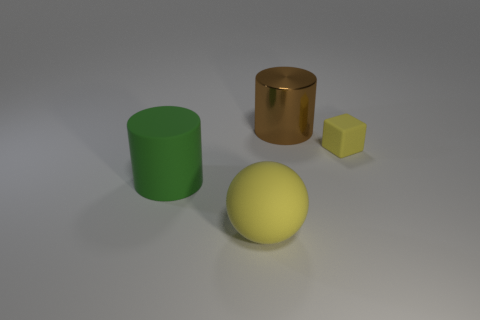Add 1 yellow metal blocks. How many objects exist? 5 Add 3 big gray cubes. How many big gray cubes exist? 3 Subtract 0 blue cubes. How many objects are left? 4 Subtract all large objects. Subtract all big green matte cylinders. How many objects are left? 0 Add 1 brown objects. How many brown objects are left? 2 